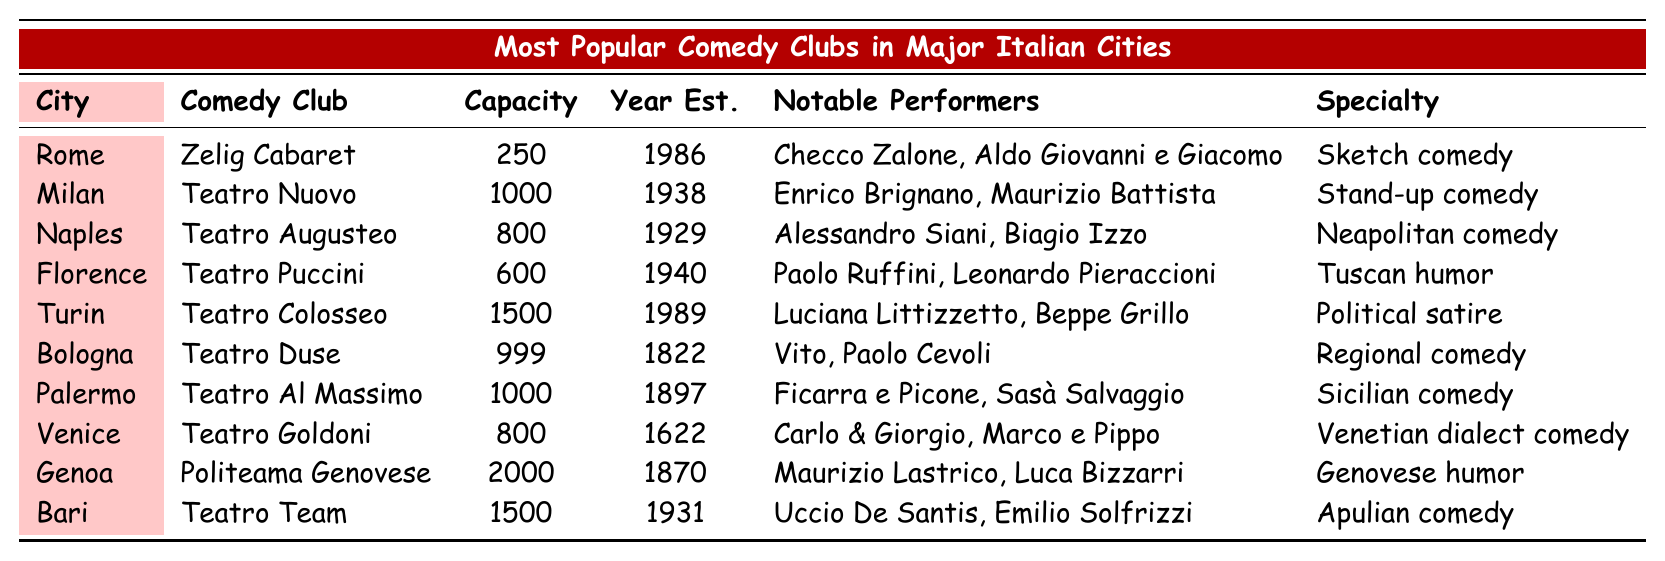What city has the highest capacity comedy club? The highest capacity listed in the table is 2000, found in Genoa at Politeama Genovese.
Answer: Genoa Which comedy club was established first? The earliest year established listed is 1822 for Teatro Duse in Bologna.
Answer: Teatro Duse What type of comedy is performed at Teatro Goldoni? According to the table, Teatro Goldoni specializes in Venetian dialect comedy.
Answer: Venetian dialect comedy How many years ago was Zelig Cabaret established? Zelig Cabaret was established in 1986. Given that the current year is assumed to be 2023, it is 37 years ago (2023 - 1986).
Answer: 37 years ago Which notable performers are associated with Teatro Puccini? The table states that Paolo Ruffini and Leonardo Pieraccioni are the notable performers associated with Teatro Puccini.
Answer: Paolo Ruffini, Leonardo Pieraccioni Is there a comedy club in Milan that specializes in sketch comedy? No, Teatro Nuovo in Milan specializes in stand-up comedy, not sketch comedy.
Answer: No Which city has the most comedy clubs with a capacity of 1000 or more? The cities with comedy clubs of at least 1000 capacity are Milan, Palermo, and Bari. Among these three, Milan has the highest capacity at 1000 (Teatro Nuovo) while both Palermo and Bari also have a capacity of 1000 (Teatro Al Massimo and Teatro Team). So, there are three cities with such clubs, but Milan has the highest single capacity.
Answer: Three What is the average capacity of all the comedy clubs listed? The total capacity is 250 + 1000 + 800 + 600 + 1500 + 999 + 1000 + 800 + 2000 + 1500 = 10,449. There are 10 clubs, so the average capacity is 10,449 / 10 = 1,044.9.
Answer: 1,044.9 Which comedy club specializes in political satire? Teatro Colosseo in Turin specializes in political satire according to the table.
Answer: Teatro Colosseo Are there any comedy clubs established after 2000? No, all the comedy clubs listed in the table were established before 2000.
Answer: No 